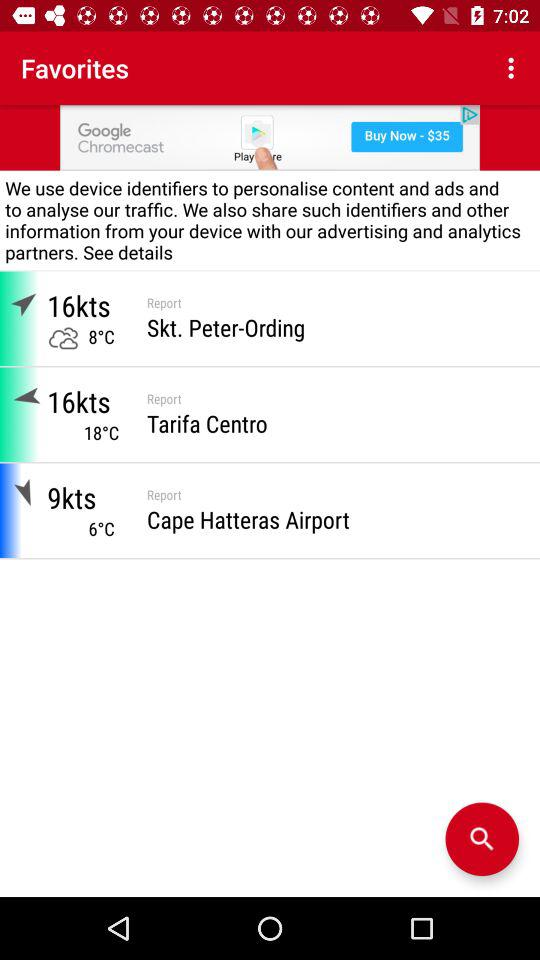What is the temperature at "Cape Hatteras Airport"? The temperature at "Cape Hatteras Airport" is 6 degrees Celsius. 